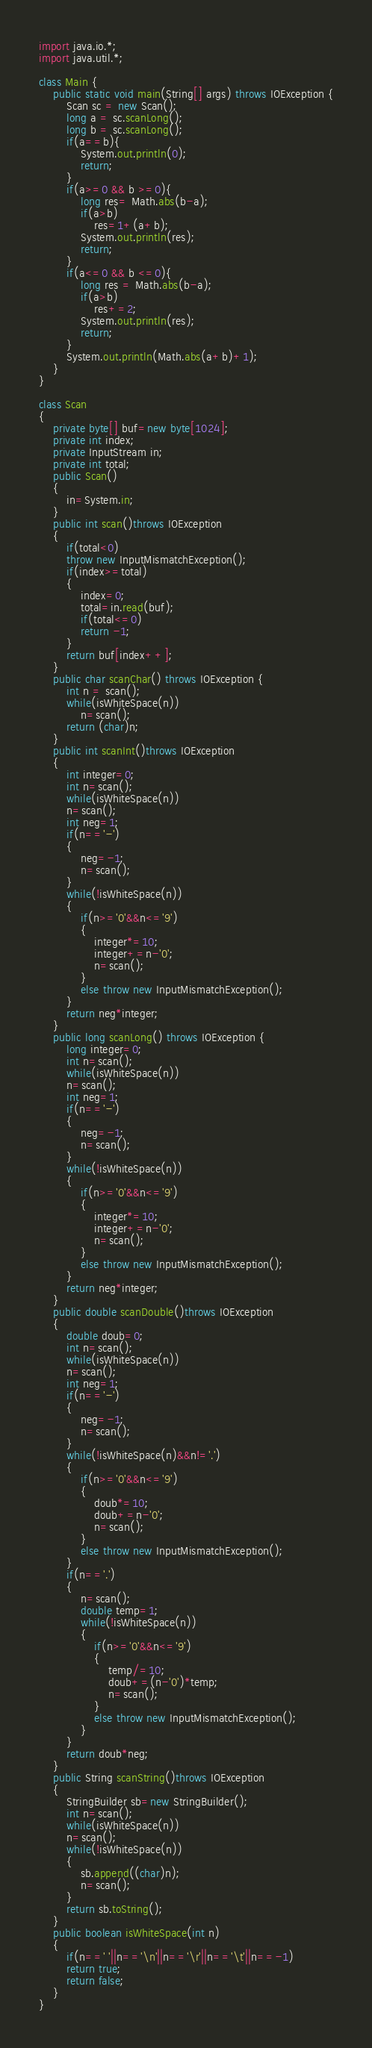<code> <loc_0><loc_0><loc_500><loc_500><_Java_>import java.io.*;
import java.util.*;

class Main {
    public static void main(String[] args) throws IOException {
        Scan sc = new Scan();
        long a = sc.scanLong();
        long b = sc.scanLong();
        if(a==b){
            System.out.println(0);
            return;
        }
        if(a>=0 && b >=0){
            long res= Math.abs(b-a);
            if(a>b)
                res=1+(a+b);
            System.out.println(res);
            return;
        }
        if(a<=0 && b <=0){
            long res = Math.abs(b-a);
            if(a>b)
                res+=2;
            System.out.println(res);
            return;
        }
        System.out.println(Math.abs(a+b)+1);
    }
}

class Scan
{
    private byte[] buf=new byte[1024];
    private int index;
    private InputStream in;
    private int total;
    public Scan()
    {
        in=System.in;
    }
    public int scan()throws IOException
    {
        if(total<0)
        throw new InputMismatchException();
        if(index>=total)
        {
            index=0;
            total=in.read(buf);
            if(total<=0)
            return -1;
        }
        return buf[index++];
    }
    public char scanChar() throws IOException {
        int n = scan();
        while(isWhiteSpace(n))
            n=scan();
        return (char)n;
    }
    public int scanInt()throws IOException
    {
        int integer=0;
        int n=scan();
        while(isWhiteSpace(n))
        n=scan();
        int neg=1;
        if(n=='-')
        {
            neg=-1;
            n=scan();
        }
        while(!isWhiteSpace(n))
        {
            if(n>='0'&&n<='9')
            {
                integer*=10;
                integer+=n-'0';
                n=scan();
            }
            else throw new InputMismatchException();
        }
        return neg*integer;
    }
    public long scanLong() throws IOException {
        long integer=0;
        int n=scan();
        while(isWhiteSpace(n))
        n=scan();
        int neg=1;
        if(n=='-')
        {
            neg=-1;
            n=scan();
        }
        while(!isWhiteSpace(n))
        {
            if(n>='0'&&n<='9')
            {
                integer*=10;
                integer+=n-'0';
                n=scan();
            }
            else throw new InputMismatchException();
        }
        return neg*integer;
    }
    public double scanDouble()throws IOException
    {
        double doub=0;
        int n=scan();
        while(isWhiteSpace(n))
        n=scan();
        int neg=1;
        if(n=='-')
        {
            neg=-1;
            n=scan();
        }
        while(!isWhiteSpace(n)&&n!='.')
        {
            if(n>='0'&&n<='9')
            {
                doub*=10;
                doub+=n-'0';
                n=scan();
            }
            else throw new InputMismatchException();
        }
        if(n=='.')
        {
            n=scan();
            double temp=1;
            while(!isWhiteSpace(n))
            {
                if(n>='0'&&n<='9')
                {
                    temp/=10;
                    doub+=(n-'0')*temp;
                    n=scan();
                }
                else throw new InputMismatchException();
            }
        }
        return doub*neg;
    }
    public String scanString()throws IOException
    {
        StringBuilder sb=new StringBuilder();
        int n=scan();
        while(isWhiteSpace(n))
        n=scan();
        while(!isWhiteSpace(n))
        {
            sb.append((char)n);
            n=scan();
        }
        return sb.toString();
    }
    public boolean isWhiteSpace(int n)
    {
        if(n==' '||n=='\n'||n=='\r'||n=='\t'||n==-1)
        return true;
        return false;
    }
}
</code> 